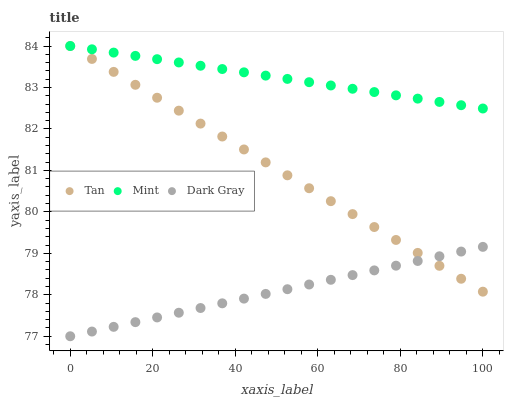Does Dark Gray have the minimum area under the curve?
Answer yes or no. Yes. Does Mint have the maximum area under the curve?
Answer yes or no. Yes. Does Tan have the minimum area under the curve?
Answer yes or no. No. Does Tan have the maximum area under the curve?
Answer yes or no. No. Is Mint the smoothest?
Answer yes or no. Yes. Is Dark Gray the roughest?
Answer yes or no. Yes. Is Tan the smoothest?
Answer yes or no. No. Is Tan the roughest?
Answer yes or no. No. Does Dark Gray have the lowest value?
Answer yes or no. Yes. Does Tan have the lowest value?
Answer yes or no. No. Does Mint have the highest value?
Answer yes or no. Yes. Is Dark Gray less than Mint?
Answer yes or no. Yes. Is Mint greater than Dark Gray?
Answer yes or no. Yes. Does Tan intersect Mint?
Answer yes or no. Yes. Is Tan less than Mint?
Answer yes or no. No. Is Tan greater than Mint?
Answer yes or no. No. Does Dark Gray intersect Mint?
Answer yes or no. No. 